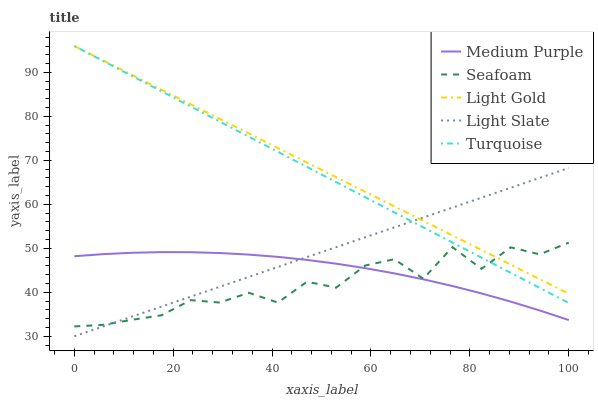Does Light Slate have the minimum area under the curve?
Answer yes or no. No. Does Light Slate have the maximum area under the curve?
Answer yes or no. No. Is Light Slate the smoothest?
Answer yes or no. No. Is Light Slate the roughest?
Answer yes or no. No. Does Turquoise have the lowest value?
Answer yes or no. No. Does Light Slate have the highest value?
Answer yes or no. No. Is Medium Purple less than Light Gold?
Answer yes or no. Yes. Is Light Gold greater than Medium Purple?
Answer yes or no. Yes. Does Medium Purple intersect Light Gold?
Answer yes or no. No. 